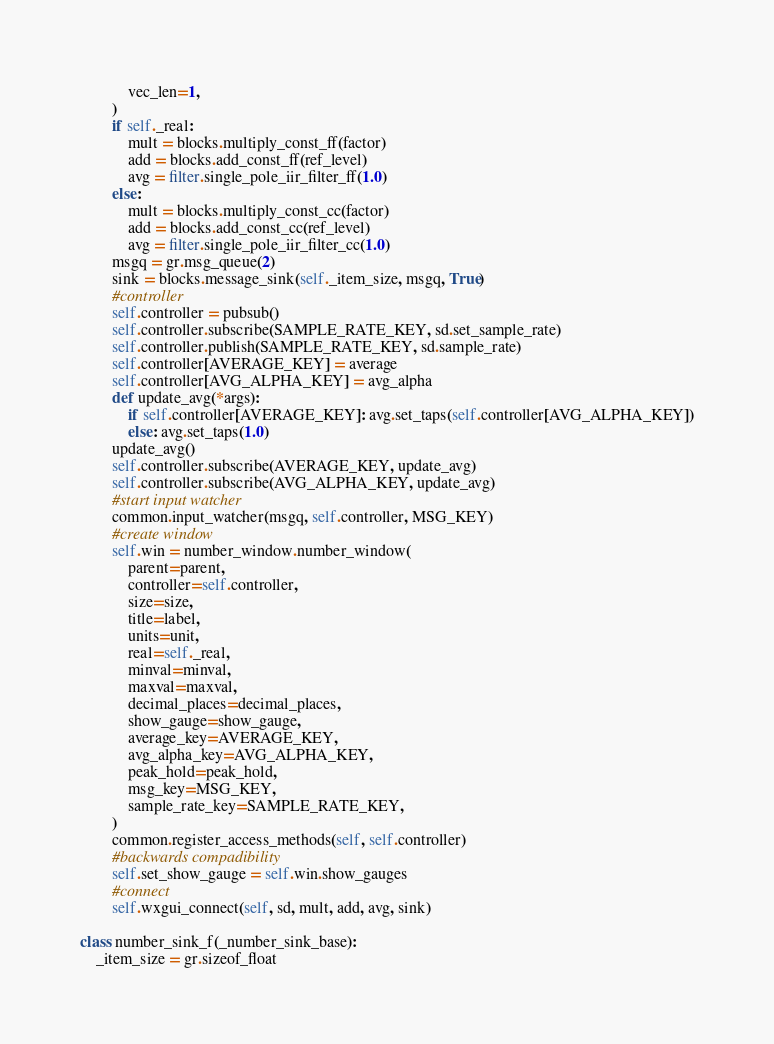Convert code to text. <code><loc_0><loc_0><loc_500><loc_500><_Python_>			vec_len=1,
		)
		if self._real:
			mult = blocks.multiply_const_ff(factor)
			add = blocks.add_const_ff(ref_level)
			avg = filter.single_pole_iir_filter_ff(1.0)
		else:
			mult = blocks.multiply_const_cc(factor)
			add = blocks.add_const_cc(ref_level)
			avg = filter.single_pole_iir_filter_cc(1.0)
		msgq = gr.msg_queue(2)
		sink = blocks.message_sink(self._item_size, msgq, True)
		#controller
		self.controller = pubsub()
		self.controller.subscribe(SAMPLE_RATE_KEY, sd.set_sample_rate)
		self.controller.publish(SAMPLE_RATE_KEY, sd.sample_rate)
		self.controller[AVERAGE_KEY] = average
		self.controller[AVG_ALPHA_KEY] = avg_alpha
		def update_avg(*args):
			if self.controller[AVERAGE_KEY]: avg.set_taps(self.controller[AVG_ALPHA_KEY])
			else: avg.set_taps(1.0)
		update_avg()
		self.controller.subscribe(AVERAGE_KEY, update_avg)
		self.controller.subscribe(AVG_ALPHA_KEY, update_avg)
		#start input watcher
		common.input_watcher(msgq, self.controller, MSG_KEY)
		#create window
		self.win = number_window.number_window(
			parent=parent,
			controller=self.controller,
			size=size,
			title=label,
			units=unit,
			real=self._real,
			minval=minval,
			maxval=maxval,
			decimal_places=decimal_places,
			show_gauge=show_gauge,
			average_key=AVERAGE_KEY,
			avg_alpha_key=AVG_ALPHA_KEY,
			peak_hold=peak_hold,
			msg_key=MSG_KEY,
			sample_rate_key=SAMPLE_RATE_KEY,
		)
		common.register_access_methods(self, self.controller)
		#backwards compadibility
		self.set_show_gauge = self.win.show_gauges
		#connect
		self.wxgui_connect(self, sd, mult, add, avg, sink)

class number_sink_f(_number_sink_base):
	_item_size = gr.sizeof_float</code> 